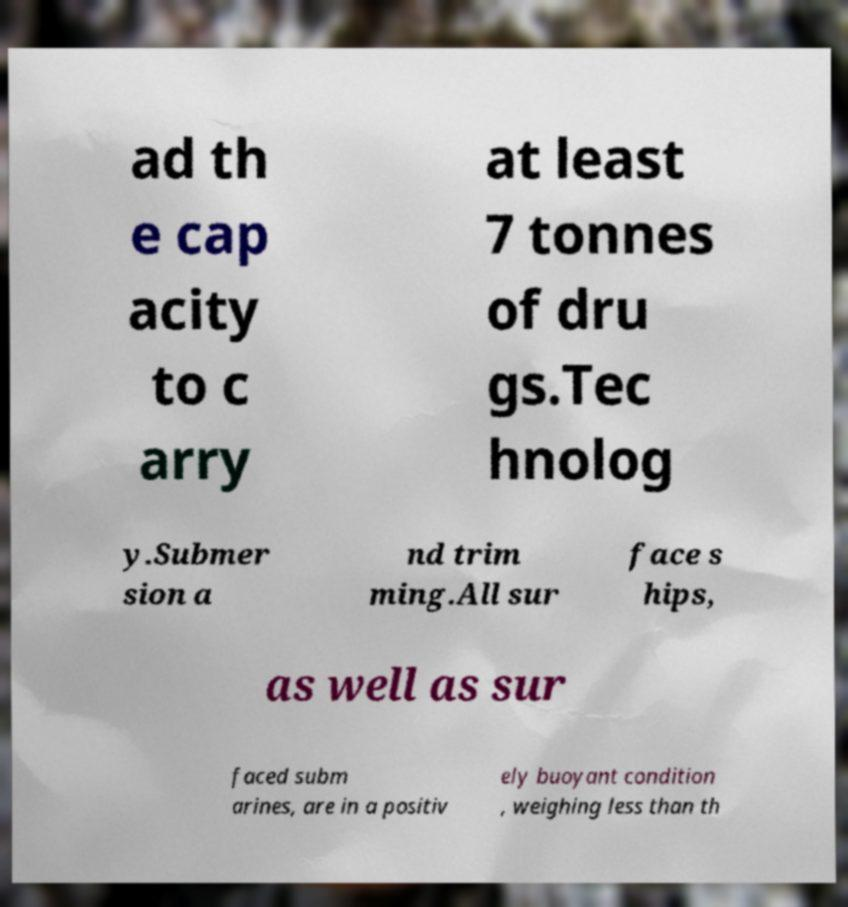What messages or text are displayed in this image? I need them in a readable, typed format. ad th e cap acity to c arry at least 7 tonnes of dru gs.Tec hnolog y.Submer sion a nd trim ming.All sur face s hips, as well as sur faced subm arines, are in a positiv ely buoyant condition , weighing less than th 